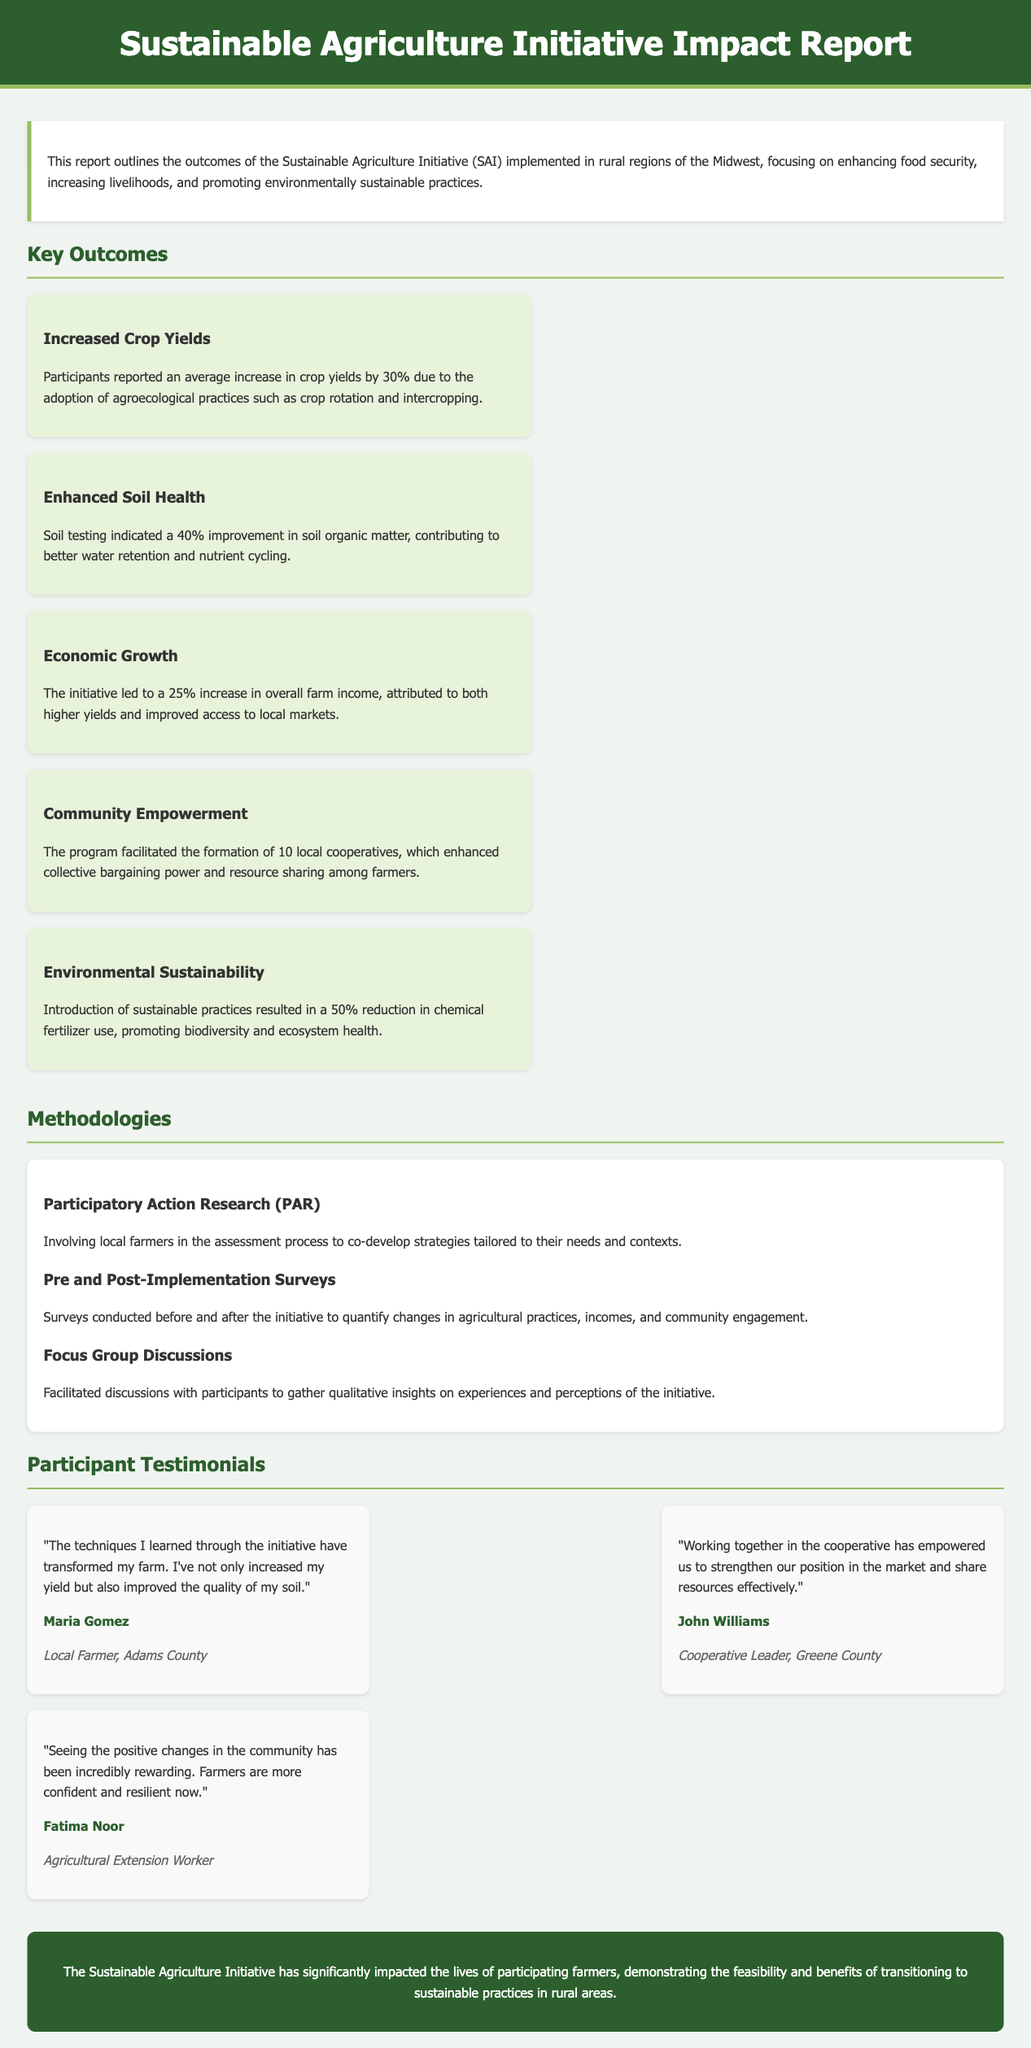What was the average increase in crop yields? The average increase in crop yields reported by participants was 30%.
Answer: 30% How much did soil organic matter improve? Soil testing indicated a 40% improvement in soil organic matter.
Answer: 40% What percentage reduction in chemical fertilizer use was achieved? The introduction of sustainable practices resulted in a 50% reduction in chemical fertilizer use.
Answer: 50% How many local cooperatives were formed? The program facilitated the formation of 10 local cooperatives.
Answer: 10 What methodologies were used in the impact assessment? Methodologies included Participatory Action Research, Pre and Post-Implementation Surveys, and Focus Group Discussions.
Answer: Participatory Action Research, Pre and Post-Implementation Surveys, Focus Group Discussions Who is Maria Gomez? Maria Gomez is a Local Farmer from Adams County who provided a testimonial.
Answer: Local Farmer, Adams County What key focus areas did the initiative aim to enhance? The initiative focused on enhancing food security, increasing livelihoods, and promoting environmentally sustainable practices.
Answer: Food security, livelihoods, environmentally sustainable practices What was the conclusion about the impact of the initiative? The conclusion stated that the Sustainable Agriculture Initiative has significantly impacted the lives of participating farmers.
Answer: Significantly impacted lives of participating farmers 